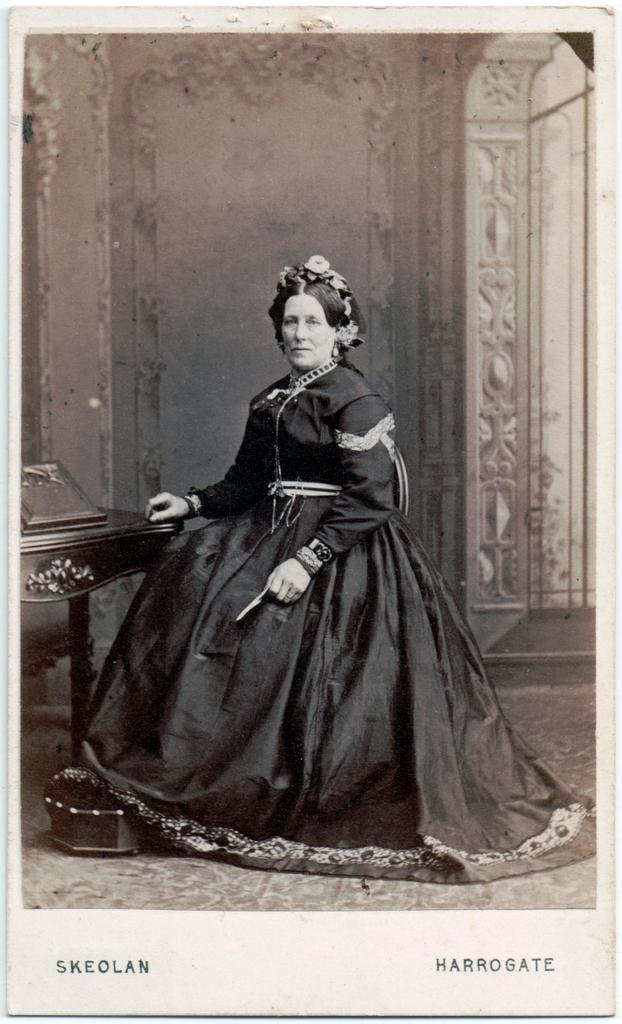Who is present in the image? There is a woman in the image. What is the woman doing in the image? The woman is sitting on a chair. What can be seen behind the woman? There is a wall behind the woman. What color scheme is used in the image? The image is in black and white color. What type of crook can be seen in the woman's hand in the image? There is no crook present in the image; the woman is not holding anything. 